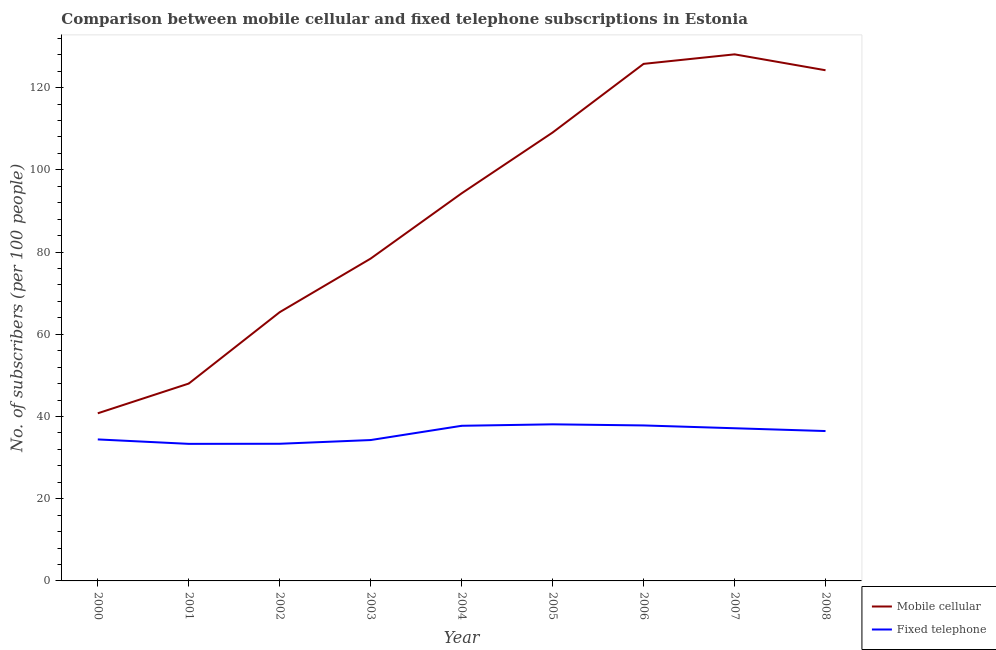Does the line corresponding to number of mobile cellular subscribers intersect with the line corresponding to number of fixed telephone subscribers?
Make the answer very short. No. Is the number of lines equal to the number of legend labels?
Make the answer very short. Yes. What is the number of mobile cellular subscribers in 2008?
Provide a succinct answer. 124.21. Across all years, what is the maximum number of fixed telephone subscribers?
Give a very brief answer. 38.09. Across all years, what is the minimum number of fixed telephone subscribers?
Make the answer very short. 33.34. In which year was the number of mobile cellular subscribers minimum?
Provide a succinct answer. 2000. What is the total number of mobile cellular subscribers in the graph?
Your answer should be very brief. 813.96. What is the difference between the number of mobile cellular subscribers in 2002 and that in 2007?
Provide a short and direct response. -62.71. What is the difference between the number of fixed telephone subscribers in 2003 and the number of mobile cellular subscribers in 2001?
Provide a succinct answer. -13.74. What is the average number of fixed telephone subscribers per year?
Make the answer very short. 35.85. In the year 2003, what is the difference between the number of mobile cellular subscribers and number of fixed telephone subscribers?
Provide a short and direct response. 44.14. What is the ratio of the number of mobile cellular subscribers in 2001 to that in 2008?
Give a very brief answer. 0.39. What is the difference between the highest and the second highest number of fixed telephone subscribers?
Ensure brevity in your answer.  0.27. What is the difference between the highest and the lowest number of mobile cellular subscribers?
Ensure brevity in your answer.  87.31. Does the number of fixed telephone subscribers monotonically increase over the years?
Provide a short and direct response. No. Is the number of fixed telephone subscribers strictly greater than the number of mobile cellular subscribers over the years?
Your answer should be very brief. No. How many years are there in the graph?
Keep it short and to the point. 9. Are the values on the major ticks of Y-axis written in scientific E-notation?
Offer a very short reply. No. Does the graph contain grids?
Keep it short and to the point. No. How many legend labels are there?
Keep it short and to the point. 2. How are the legend labels stacked?
Your response must be concise. Vertical. What is the title of the graph?
Offer a terse response. Comparison between mobile cellular and fixed telephone subscriptions in Estonia. Does "Not attending school" appear as one of the legend labels in the graph?
Provide a short and direct response. No. What is the label or title of the Y-axis?
Keep it short and to the point. No. of subscribers (per 100 people). What is the No. of subscribers (per 100 people) of Mobile cellular in 2000?
Offer a very short reply. 40.77. What is the No. of subscribers (per 100 people) of Fixed telephone in 2000?
Keep it short and to the point. 34.42. What is the No. of subscribers (per 100 people) in Mobile cellular in 2001?
Your answer should be very brief. 48. What is the No. of subscribers (per 100 people) of Fixed telephone in 2001?
Make the answer very short. 33.34. What is the No. of subscribers (per 100 people) of Mobile cellular in 2002?
Offer a very short reply. 65.37. What is the No. of subscribers (per 100 people) in Fixed telephone in 2002?
Your answer should be compact. 33.36. What is the No. of subscribers (per 100 people) of Mobile cellular in 2003?
Provide a short and direct response. 78.41. What is the No. of subscribers (per 100 people) in Fixed telephone in 2003?
Offer a very short reply. 34.26. What is the No. of subscribers (per 100 people) of Mobile cellular in 2004?
Make the answer very short. 94.28. What is the No. of subscribers (per 100 people) of Fixed telephone in 2004?
Keep it short and to the point. 37.73. What is the No. of subscribers (per 100 people) of Mobile cellular in 2005?
Provide a short and direct response. 109.07. What is the No. of subscribers (per 100 people) of Fixed telephone in 2005?
Give a very brief answer. 38.09. What is the No. of subscribers (per 100 people) in Mobile cellular in 2006?
Provide a short and direct response. 125.76. What is the No. of subscribers (per 100 people) of Fixed telephone in 2006?
Give a very brief answer. 37.82. What is the No. of subscribers (per 100 people) in Mobile cellular in 2007?
Provide a short and direct response. 128.08. What is the No. of subscribers (per 100 people) of Fixed telephone in 2007?
Provide a short and direct response. 37.14. What is the No. of subscribers (per 100 people) of Mobile cellular in 2008?
Offer a terse response. 124.21. What is the No. of subscribers (per 100 people) in Fixed telephone in 2008?
Your answer should be compact. 36.45. Across all years, what is the maximum No. of subscribers (per 100 people) of Mobile cellular?
Your answer should be compact. 128.08. Across all years, what is the maximum No. of subscribers (per 100 people) of Fixed telephone?
Ensure brevity in your answer.  38.09. Across all years, what is the minimum No. of subscribers (per 100 people) of Mobile cellular?
Provide a short and direct response. 40.77. Across all years, what is the minimum No. of subscribers (per 100 people) of Fixed telephone?
Offer a very short reply. 33.34. What is the total No. of subscribers (per 100 people) in Mobile cellular in the graph?
Ensure brevity in your answer.  813.96. What is the total No. of subscribers (per 100 people) in Fixed telephone in the graph?
Keep it short and to the point. 322.61. What is the difference between the No. of subscribers (per 100 people) in Mobile cellular in 2000 and that in 2001?
Provide a succinct answer. -7.23. What is the difference between the No. of subscribers (per 100 people) in Fixed telephone in 2000 and that in 2001?
Your response must be concise. 1.08. What is the difference between the No. of subscribers (per 100 people) of Mobile cellular in 2000 and that in 2002?
Your answer should be compact. -24.6. What is the difference between the No. of subscribers (per 100 people) of Fixed telephone in 2000 and that in 2002?
Ensure brevity in your answer.  1.06. What is the difference between the No. of subscribers (per 100 people) in Mobile cellular in 2000 and that in 2003?
Your answer should be very brief. -37.64. What is the difference between the No. of subscribers (per 100 people) in Fixed telephone in 2000 and that in 2003?
Offer a very short reply. 0.15. What is the difference between the No. of subscribers (per 100 people) of Mobile cellular in 2000 and that in 2004?
Provide a succinct answer. -53.51. What is the difference between the No. of subscribers (per 100 people) in Fixed telephone in 2000 and that in 2004?
Your answer should be compact. -3.32. What is the difference between the No. of subscribers (per 100 people) in Mobile cellular in 2000 and that in 2005?
Keep it short and to the point. -68.3. What is the difference between the No. of subscribers (per 100 people) in Fixed telephone in 2000 and that in 2005?
Your response must be concise. -3.67. What is the difference between the No. of subscribers (per 100 people) in Mobile cellular in 2000 and that in 2006?
Provide a short and direct response. -84.99. What is the difference between the No. of subscribers (per 100 people) of Fixed telephone in 2000 and that in 2006?
Your answer should be compact. -3.4. What is the difference between the No. of subscribers (per 100 people) of Mobile cellular in 2000 and that in 2007?
Ensure brevity in your answer.  -87.31. What is the difference between the No. of subscribers (per 100 people) of Fixed telephone in 2000 and that in 2007?
Keep it short and to the point. -2.72. What is the difference between the No. of subscribers (per 100 people) of Mobile cellular in 2000 and that in 2008?
Your answer should be compact. -83.44. What is the difference between the No. of subscribers (per 100 people) of Fixed telephone in 2000 and that in 2008?
Your answer should be very brief. -2.04. What is the difference between the No. of subscribers (per 100 people) of Mobile cellular in 2001 and that in 2002?
Give a very brief answer. -17.37. What is the difference between the No. of subscribers (per 100 people) of Fixed telephone in 2001 and that in 2002?
Your answer should be very brief. -0.02. What is the difference between the No. of subscribers (per 100 people) of Mobile cellular in 2001 and that in 2003?
Your response must be concise. -30.4. What is the difference between the No. of subscribers (per 100 people) in Fixed telephone in 2001 and that in 2003?
Your answer should be very brief. -0.93. What is the difference between the No. of subscribers (per 100 people) of Mobile cellular in 2001 and that in 2004?
Your answer should be very brief. -46.27. What is the difference between the No. of subscribers (per 100 people) of Fixed telephone in 2001 and that in 2004?
Make the answer very short. -4.4. What is the difference between the No. of subscribers (per 100 people) of Mobile cellular in 2001 and that in 2005?
Offer a terse response. -61.07. What is the difference between the No. of subscribers (per 100 people) in Fixed telephone in 2001 and that in 2005?
Offer a terse response. -4.75. What is the difference between the No. of subscribers (per 100 people) in Mobile cellular in 2001 and that in 2006?
Your answer should be very brief. -77.76. What is the difference between the No. of subscribers (per 100 people) of Fixed telephone in 2001 and that in 2006?
Make the answer very short. -4.48. What is the difference between the No. of subscribers (per 100 people) of Mobile cellular in 2001 and that in 2007?
Provide a succinct answer. -80.07. What is the difference between the No. of subscribers (per 100 people) in Fixed telephone in 2001 and that in 2007?
Your answer should be compact. -3.8. What is the difference between the No. of subscribers (per 100 people) of Mobile cellular in 2001 and that in 2008?
Your answer should be very brief. -76.21. What is the difference between the No. of subscribers (per 100 people) of Fixed telephone in 2001 and that in 2008?
Provide a succinct answer. -3.12. What is the difference between the No. of subscribers (per 100 people) in Mobile cellular in 2002 and that in 2003?
Provide a short and direct response. -13.04. What is the difference between the No. of subscribers (per 100 people) in Fixed telephone in 2002 and that in 2003?
Your answer should be compact. -0.91. What is the difference between the No. of subscribers (per 100 people) in Mobile cellular in 2002 and that in 2004?
Give a very brief answer. -28.91. What is the difference between the No. of subscribers (per 100 people) in Fixed telephone in 2002 and that in 2004?
Provide a succinct answer. -4.37. What is the difference between the No. of subscribers (per 100 people) of Mobile cellular in 2002 and that in 2005?
Make the answer very short. -43.7. What is the difference between the No. of subscribers (per 100 people) of Fixed telephone in 2002 and that in 2005?
Give a very brief answer. -4.73. What is the difference between the No. of subscribers (per 100 people) of Mobile cellular in 2002 and that in 2006?
Give a very brief answer. -60.39. What is the difference between the No. of subscribers (per 100 people) in Fixed telephone in 2002 and that in 2006?
Offer a terse response. -4.46. What is the difference between the No. of subscribers (per 100 people) in Mobile cellular in 2002 and that in 2007?
Your response must be concise. -62.71. What is the difference between the No. of subscribers (per 100 people) of Fixed telephone in 2002 and that in 2007?
Your response must be concise. -3.78. What is the difference between the No. of subscribers (per 100 people) of Mobile cellular in 2002 and that in 2008?
Offer a very short reply. -58.84. What is the difference between the No. of subscribers (per 100 people) of Fixed telephone in 2002 and that in 2008?
Give a very brief answer. -3.1. What is the difference between the No. of subscribers (per 100 people) in Mobile cellular in 2003 and that in 2004?
Offer a very short reply. -15.87. What is the difference between the No. of subscribers (per 100 people) of Fixed telephone in 2003 and that in 2004?
Give a very brief answer. -3.47. What is the difference between the No. of subscribers (per 100 people) of Mobile cellular in 2003 and that in 2005?
Keep it short and to the point. -30.66. What is the difference between the No. of subscribers (per 100 people) of Fixed telephone in 2003 and that in 2005?
Ensure brevity in your answer.  -3.82. What is the difference between the No. of subscribers (per 100 people) in Mobile cellular in 2003 and that in 2006?
Your response must be concise. -47.36. What is the difference between the No. of subscribers (per 100 people) of Fixed telephone in 2003 and that in 2006?
Your answer should be compact. -3.55. What is the difference between the No. of subscribers (per 100 people) in Mobile cellular in 2003 and that in 2007?
Give a very brief answer. -49.67. What is the difference between the No. of subscribers (per 100 people) of Fixed telephone in 2003 and that in 2007?
Provide a short and direct response. -2.87. What is the difference between the No. of subscribers (per 100 people) in Mobile cellular in 2003 and that in 2008?
Make the answer very short. -45.8. What is the difference between the No. of subscribers (per 100 people) in Fixed telephone in 2003 and that in 2008?
Provide a short and direct response. -2.19. What is the difference between the No. of subscribers (per 100 people) of Mobile cellular in 2004 and that in 2005?
Your answer should be compact. -14.79. What is the difference between the No. of subscribers (per 100 people) of Fixed telephone in 2004 and that in 2005?
Your response must be concise. -0.35. What is the difference between the No. of subscribers (per 100 people) in Mobile cellular in 2004 and that in 2006?
Keep it short and to the point. -31.49. What is the difference between the No. of subscribers (per 100 people) in Fixed telephone in 2004 and that in 2006?
Keep it short and to the point. -0.08. What is the difference between the No. of subscribers (per 100 people) of Mobile cellular in 2004 and that in 2007?
Keep it short and to the point. -33.8. What is the difference between the No. of subscribers (per 100 people) of Fixed telephone in 2004 and that in 2007?
Your response must be concise. 0.6. What is the difference between the No. of subscribers (per 100 people) of Mobile cellular in 2004 and that in 2008?
Provide a short and direct response. -29.93. What is the difference between the No. of subscribers (per 100 people) of Fixed telephone in 2004 and that in 2008?
Provide a succinct answer. 1.28. What is the difference between the No. of subscribers (per 100 people) of Mobile cellular in 2005 and that in 2006?
Provide a short and direct response. -16.69. What is the difference between the No. of subscribers (per 100 people) of Fixed telephone in 2005 and that in 2006?
Your answer should be very brief. 0.27. What is the difference between the No. of subscribers (per 100 people) of Mobile cellular in 2005 and that in 2007?
Keep it short and to the point. -19.01. What is the difference between the No. of subscribers (per 100 people) of Fixed telephone in 2005 and that in 2007?
Make the answer very short. 0.95. What is the difference between the No. of subscribers (per 100 people) in Mobile cellular in 2005 and that in 2008?
Make the answer very short. -15.14. What is the difference between the No. of subscribers (per 100 people) in Fixed telephone in 2005 and that in 2008?
Make the answer very short. 1.63. What is the difference between the No. of subscribers (per 100 people) of Mobile cellular in 2006 and that in 2007?
Your answer should be very brief. -2.31. What is the difference between the No. of subscribers (per 100 people) in Fixed telephone in 2006 and that in 2007?
Your response must be concise. 0.68. What is the difference between the No. of subscribers (per 100 people) of Mobile cellular in 2006 and that in 2008?
Offer a terse response. 1.55. What is the difference between the No. of subscribers (per 100 people) in Fixed telephone in 2006 and that in 2008?
Your answer should be very brief. 1.36. What is the difference between the No. of subscribers (per 100 people) in Mobile cellular in 2007 and that in 2008?
Give a very brief answer. 3.87. What is the difference between the No. of subscribers (per 100 people) in Fixed telephone in 2007 and that in 2008?
Offer a terse response. 0.68. What is the difference between the No. of subscribers (per 100 people) in Mobile cellular in 2000 and the No. of subscribers (per 100 people) in Fixed telephone in 2001?
Make the answer very short. 7.43. What is the difference between the No. of subscribers (per 100 people) in Mobile cellular in 2000 and the No. of subscribers (per 100 people) in Fixed telephone in 2002?
Give a very brief answer. 7.41. What is the difference between the No. of subscribers (per 100 people) of Mobile cellular in 2000 and the No. of subscribers (per 100 people) of Fixed telephone in 2003?
Give a very brief answer. 6.51. What is the difference between the No. of subscribers (per 100 people) of Mobile cellular in 2000 and the No. of subscribers (per 100 people) of Fixed telephone in 2004?
Provide a succinct answer. 3.04. What is the difference between the No. of subscribers (per 100 people) in Mobile cellular in 2000 and the No. of subscribers (per 100 people) in Fixed telephone in 2005?
Keep it short and to the point. 2.68. What is the difference between the No. of subscribers (per 100 people) of Mobile cellular in 2000 and the No. of subscribers (per 100 people) of Fixed telephone in 2006?
Provide a short and direct response. 2.95. What is the difference between the No. of subscribers (per 100 people) in Mobile cellular in 2000 and the No. of subscribers (per 100 people) in Fixed telephone in 2007?
Provide a short and direct response. 3.64. What is the difference between the No. of subscribers (per 100 people) in Mobile cellular in 2000 and the No. of subscribers (per 100 people) in Fixed telephone in 2008?
Your answer should be compact. 4.32. What is the difference between the No. of subscribers (per 100 people) of Mobile cellular in 2001 and the No. of subscribers (per 100 people) of Fixed telephone in 2002?
Ensure brevity in your answer.  14.65. What is the difference between the No. of subscribers (per 100 people) in Mobile cellular in 2001 and the No. of subscribers (per 100 people) in Fixed telephone in 2003?
Provide a succinct answer. 13.74. What is the difference between the No. of subscribers (per 100 people) of Mobile cellular in 2001 and the No. of subscribers (per 100 people) of Fixed telephone in 2004?
Make the answer very short. 10.27. What is the difference between the No. of subscribers (per 100 people) in Mobile cellular in 2001 and the No. of subscribers (per 100 people) in Fixed telephone in 2005?
Your answer should be very brief. 9.92. What is the difference between the No. of subscribers (per 100 people) of Mobile cellular in 2001 and the No. of subscribers (per 100 people) of Fixed telephone in 2006?
Your answer should be compact. 10.19. What is the difference between the No. of subscribers (per 100 people) in Mobile cellular in 2001 and the No. of subscribers (per 100 people) in Fixed telephone in 2007?
Your answer should be very brief. 10.87. What is the difference between the No. of subscribers (per 100 people) in Mobile cellular in 2001 and the No. of subscribers (per 100 people) in Fixed telephone in 2008?
Provide a short and direct response. 11.55. What is the difference between the No. of subscribers (per 100 people) in Mobile cellular in 2002 and the No. of subscribers (per 100 people) in Fixed telephone in 2003?
Your answer should be compact. 31.11. What is the difference between the No. of subscribers (per 100 people) of Mobile cellular in 2002 and the No. of subscribers (per 100 people) of Fixed telephone in 2004?
Give a very brief answer. 27.64. What is the difference between the No. of subscribers (per 100 people) in Mobile cellular in 2002 and the No. of subscribers (per 100 people) in Fixed telephone in 2005?
Your response must be concise. 27.28. What is the difference between the No. of subscribers (per 100 people) of Mobile cellular in 2002 and the No. of subscribers (per 100 people) of Fixed telephone in 2006?
Your response must be concise. 27.55. What is the difference between the No. of subscribers (per 100 people) of Mobile cellular in 2002 and the No. of subscribers (per 100 people) of Fixed telephone in 2007?
Give a very brief answer. 28.24. What is the difference between the No. of subscribers (per 100 people) of Mobile cellular in 2002 and the No. of subscribers (per 100 people) of Fixed telephone in 2008?
Your answer should be compact. 28.92. What is the difference between the No. of subscribers (per 100 people) of Mobile cellular in 2003 and the No. of subscribers (per 100 people) of Fixed telephone in 2004?
Provide a short and direct response. 40.67. What is the difference between the No. of subscribers (per 100 people) of Mobile cellular in 2003 and the No. of subscribers (per 100 people) of Fixed telephone in 2005?
Offer a very short reply. 40.32. What is the difference between the No. of subscribers (per 100 people) in Mobile cellular in 2003 and the No. of subscribers (per 100 people) in Fixed telephone in 2006?
Keep it short and to the point. 40.59. What is the difference between the No. of subscribers (per 100 people) of Mobile cellular in 2003 and the No. of subscribers (per 100 people) of Fixed telephone in 2007?
Offer a terse response. 41.27. What is the difference between the No. of subscribers (per 100 people) of Mobile cellular in 2003 and the No. of subscribers (per 100 people) of Fixed telephone in 2008?
Offer a terse response. 41.95. What is the difference between the No. of subscribers (per 100 people) in Mobile cellular in 2004 and the No. of subscribers (per 100 people) in Fixed telephone in 2005?
Your response must be concise. 56.19. What is the difference between the No. of subscribers (per 100 people) of Mobile cellular in 2004 and the No. of subscribers (per 100 people) of Fixed telephone in 2006?
Ensure brevity in your answer.  56.46. What is the difference between the No. of subscribers (per 100 people) in Mobile cellular in 2004 and the No. of subscribers (per 100 people) in Fixed telephone in 2007?
Make the answer very short. 57.14. What is the difference between the No. of subscribers (per 100 people) in Mobile cellular in 2004 and the No. of subscribers (per 100 people) in Fixed telephone in 2008?
Provide a short and direct response. 57.82. What is the difference between the No. of subscribers (per 100 people) in Mobile cellular in 2005 and the No. of subscribers (per 100 people) in Fixed telephone in 2006?
Your answer should be very brief. 71.25. What is the difference between the No. of subscribers (per 100 people) in Mobile cellular in 2005 and the No. of subscribers (per 100 people) in Fixed telephone in 2007?
Your answer should be very brief. 71.94. What is the difference between the No. of subscribers (per 100 people) in Mobile cellular in 2005 and the No. of subscribers (per 100 people) in Fixed telephone in 2008?
Keep it short and to the point. 72.62. What is the difference between the No. of subscribers (per 100 people) of Mobile cellular in 2006 and the No. of subscribers (per 100 people) of Fixed telephone in 2007?
Your response must be concise. 88.63. What is the difference between the No. of subscribers (per 100 people) in Mobile cellular in 2006 and the No. of subscribers (per 100 people) in Fixed telephone in 2008?
Give a very brief answer. 89.31. What is the difference between the No. of subscribers (per 100 people) in Mobile cellular in 2007 and the No. of subscribers (per 100 people) in Fixed telephone in 2008?
Provide a short and direct response. 91.62. What is the average No. of subscribers (per 100 people) of Mobile cellular per year?
Provide a short and direct response. 90.44. What is the average No. of subscribers (per 100 people) in Fixed telephone per year?
Provide a succinct answer. 35.85. In the year 2000, what is the difference between the No. of subscribers (per 100 people) in Mobile cellular and No. of subscribers (per 100 people) in Fixed telephone?
Provide a short and direct response. 6.36. In the year 2001, what is the difference between the No. of subscribers (per 100 people) of Mobile cellular and No. of subscribers (per 100 people) of Fixed telephone?
Ensure brevity in your answer.  14.67. In the year 2002, what is the difference between the No. of subscribers (per 100 people) of Mobile cellular and No. of subscribers (per 100 people) of Fixed telephone?
Give a very brief answer. 32.01. In the year 2003, what is the difference between the No. of subscribers (per 100 people) of Mobile cellular and No. of subscribers (per 100 people) of Fixed telephone?
Provide a succinct answer. 44.14. In the year 2004, what is the difference between the No. of subscribers (per 100 people) of Mobile cellular and No. of subscribers (per 100 people) of Fixed telephone?
Your response must be concise. 56.55. In the year 2005, what is the difference between the No. of subscribers (per 100 people) of Mobile cellular and No. of subscribers (per 100 people) of Fixed telephone?
Your answer should be compact. 70.98. In the year 2006, what is the difference between the No. of subscribers (per 100 people) of Mobile cellular and No. of subscribers (per 100 people) of Fixed telephone?
Give a very brief answer. 87.95. In the year 2007, what is the difference between the No. of subscribers (per 100 people) of Mobile cellular and No. of subscribers (per 100 people) of Fixed telephone?
Make the answer very short. 90.94. In the year 2008, what is the difference between the No. of subscribers (per 100 people) in Mobile cellular and No. of subscribers (per 100 people) in Fixed telephone?
Offer a very short reply. 87.76. What is the ratio of the No. of subscribers (per 100 people) in Mobile cellular in 2000 to that in 2001?
Offer a very short reply. 0.85. What is the ratio of the No. of subscribers (per 100 people) in Fixed telephone in 2000 to that in 2001?
Your answer should be compact. 1.03. What is the ratio of the No. of subscribers (per 100 people) in Mobile cellular in 2000 to that in 2002?
Ensure brevity in your answer.  0.62. What is the ratio of the No. of subscribers (per 100 people) of Fixed telephone in 2000 to that in 2002?
Keep it short and to the point. 1.03. What is the ratio of the No. of subscribers (per 100 people) of Mobile cellular in 2000 to that in 2003?
Keep it short and to the point. 0.52. What is the ratio of the No. of subscribers (per 100 people) of Mobile cellular in 2000 to that in 2004?
Provide a short and direct response. 0.43. What is the ratio of the No. of subscribers (per 100 people) in Fixed telephone in 2000 to that in 2004?
Ensure brevity in your answer.  0.91. What is the ratio of the No. of subscribers (per 100 people) in Mobile cellular in 2000 to that in 2005?
Ensure brevity in your answer.  0.37. What is the ratio of the No. of subscribers (per 100 people) in Fixed telephone in 2000 to that in 2005?
Your answer should be compact. 0.9. What is the ratio of the No. of subscribers (per 100 people) of Mobile cellular in 2000 to that in 2006?
Offer a very short reply. 0.32. What is the ratio of the No. of subscribers (per 100 people) in Fixed telephone in 2000 to that in 2006?
Your answer should be compact. 0.91. What is the ratio of the No. of subscribers (per 100 people) in Mobile cellular in 2000 to that in 2007?
Provide a short and direct response. 0.32. What is the ratio of the No. of subscribers (per 100 people) of Fixed telephone in 2000 to that in 2007?
Your answer should be very brief. 0.93. What is the ratio of the No. of subscribers (per 100 people) in Mobile cellular in 2000 to that in 2008?
Keep it short and to the point. 0.33. What is the ratio of the No. of subscribers (per 100 people) in Fixed telephone in 2000 to that in 2008?
Your response must be concise. 0.94. What is the ratio of the No. of subscribers (per 100 people) of Mobile cellular in 2001 to that in 2002?
Your response must be concise. 0.73. What is the ratio of the No. of subscribers (per 100 people) in Mobile cellular in 2001 to that in 2003?
Your response must be concise. 0.61. What is the ratio of the No. of subscribers (per 100 people) of Fixed telephone in 2001 to that in 2003?
Make the answer very short. 0.97. What is the ratio of the No. of subscribers (per 100 people) in Mobile cellular in 2001 to that in 2004?
Provide a succinct answer. 0.51. What is the ratio of the No. of subscribers (per 100 people) in Fixed telephone in 2001 to that in 2004?
Provide a short and direct response. 0.88. What is the ratio of the No. of subscribers (per 100 people) of Mobile cellular in 2001 to that in 2005?
Provide a short and direct response. 0.44. What is the ratio of the No. of subscribers (per 100 people) of Fixed telephone in 2001 to that in 2005?
Offer a very short reply. 0.88. What is the ratio of the No. of subscribers (per 100 people) of Mobile cellular in 2001 to that in 2006?
Your response must be concise. 0.38. What is the ratio of the No. of subscribers (per 100 people) of Fixed telephone in 2001 to that in 2006?
Provide a short and direct response. 0.88. What is the ratio of the No. of subscribers (per 100 people) in Mobile cellular in 2001 to that in 2007?
Offer a terse response. 0.37. What is the ratio of the No. of subscribers (per 100 people) of Fixed telephone in 2001 to that in 2007?
Your response must be concise. 0.9. What is the ratio of the No. of subscribers (per 100 people) in Mobile cellular in 2001 to that in 2008?
Ensure brevity in your answer.  0.39. What is the ratio of the No. of subscribers (per 100 people) of Fixed telephone in 2001 to that in 2008?
Your response must be concise. 0.91. What is the ratio of the No. of subscribers (per 100 people) of Mobile cellular in 2002 to that in 2003?
Ensure brevity in your answer.  0.83. What is the ratio of the No. of subscribers (per 100 people) in Fixed telephone in 2002 to that in 2003?
Your answer should be very brief. 0.97. What is the ratio of the No. of subscribers (per 100 people) in Mobile cellular in 2002 to that in 2004?
Provide a short and direct response. 0.69. What is the ratio of the No. of subscribers (per 100 people) of Fixed telephone in 2002 to that in 2004?
Your response must be concise. 0.88. What is the ratio of the No. of subscribers (per 100 people) of Mobile cellular in 2002 to that in 2005?
Your answer should be compact. 0.6. What is the ratio of the No. of subscribers (per 100 people) in Fixed telephone in 2002 to that in 2005?
Your answer should be very brief. 0.88. What is the ratio of the No. of subscribers (per 100 people) of Mobile cellular in 2002 to that in 2006?
Provide a succinct answer. 0.52. What is the ratio of the No. of subscribers (per 100 people) in Fixed telephone in 2002 to that in 2006?
Give a very brief answer. 0.88. What is the ratio of the No. of subscribers (per 100 people) of Mobile cellular in 2002 to that in 2007?
Make the answer very short. 0.51. What is the ratio of the No. of subscribers (per 100 people) in Fixed telephone in 2002 to that in 2007?
Ensure brevity in your answer.  0.9. What is the ratio of the No. of subscribers (per 100 people) in Mobile cellular in 2002 to that in 2008?
Offer a terse response. 0.53. What is the ratio of the No. of subscribers (per 100 people) of Fixed telephone in 2002 to that in 2008?
Provide a succinct answer. 0.92. What is the ratio of the No. of subscribers (per 100 people) in Mobile cellular in 2003 to that in 2004?
Ensure brevity in your answer.  0.83. What is the ratio of the No. of subscribers (per 100 people) in Fixed telephone in 2003 to that in 2004?
Give a very brief answer. 0.91. What is the ratio of the No. of subscribers (per 100 people) of Mobile cellular in 2003 to that in 2005?
Provide a short and direct response. 0.72. What is the ratio of the No. of subscribers (per 100 people) of Fixed telephone in 2003 to that in 2005?
Your answer should be compact. 0.9. What is the ratio of the No. of subscribers (per 100 people) of Mobile cellular in 2003 to that in 2006?
Your answer should be very brief. 0.62. What is the ratio of the No. of subscribers (per 100 people) in Fixed telephone in 2003 to that in 2006?
Your answer should be very brief. 0.91. What is the ratio of the No. of subscribers (per 100 people) of Mobile cellular in 2003 to that in 2007?
Provide a succinct answer. 0.61. What is the ratio of the No. of subscribers (per 100 people) in Fixed telephone in 2003 to that in 2007?
Ensure brevity in your answer.  0.92. What is the ratio of the No. of subscribers (per 100 people) of Mobile cellular in 2003 to that in 2008?
Offer a very short reply. 0.63. What is the ratio of the No. of subscribers (per 100 people) of Fixed telephone in 2003 to that in 2008?
Your answer should be compact. 0.94. What is the ratio of the No. of subscribers (per 100 people) of Mobile cellular in 2004 to that in 2005?
Ensure brevity in your answer.  0.86. What is the ratio of the No. of subscribers (per 100 people) of Mobile cellular in 2004 to that in 2006?
Provide a succinct answer. 0.75. What is the ratio of the No. of subscribers (per 100 people) in Fixed telephone in 2004 to that in 2006?
Make the answer very short. 1. What is the ratio of the No. of subscribers (per 100 people) in Mobile cellular in 2004 to that in 2007?
Your response must be concise. 0.74. What is the ratio of the No. of subscribers (per 100 people) of Fixed telephone in 2004 to that in 2007?
Provide a short and direct response. 1.02. What is the ratio of the No. of subscribers (per 100 people) of Mobile cellular in 2004 to that in 2008?
Your response must be concise. 0.76. What is the ratio of the No. of subscribers (per 100 people) of Fixed telephone in 2004 to that in 2008?
Offer a very short reply. 1.04. What is the ratio of the No. of subscribers (per 100 people) in Mobile cellular in 2005 to that in 2006?
Your answer should be compact. 0.87. What is the ratio of the No. of subscribers (per 100 people) of Fixed telephone in 2005 to that in 2006?
Keep it short and to the point. 1.01. What is the ratio of the No. of subscribers (per 100 people) in Mobile cellular in 2005 to that in 2007?
Keep it short and to the point. 0.85. What is the ratio of the No. of subscribers (per 100 people) in Fixed telephone in 2005 to that in 2007?
Your answer should be very brief. 1.03. What is the ratio of the No. of subscribers (per 100 people) in Mobile cellular in 2005 to that in 2008?
Give a very brief answer. 0.88. What is the ratio of the No. of subscribers (per 100 people) of Fixed telephone in 2005 to that in 2008?
Your response must be concise. 1.04. What is the ratio of the No. of subscribers (per 100 people) in Mobile cellular in 2006 to that in 2007?
Give a very brief answer. 0.98. What is the ratio of the No. of subscribers (per 100 people) in Fixed telephone in 2006 to that in 2007?
Keep it short and to the point. 1.02. What is the ratio of the No. of subscribers (per 100 people) of Mobile cellular in 2006 to that in 2008?
Keep it short and to the point. 1.01. What is the ratio of the No. of subscribers (per 100 people) of Fixed telephone in 2006 to that in 2008?
Offer a terse response. 1.04. What is the ratio of the No. of subscribers (per 100 people) in Mobile cellular in 2007 to that in 2008?
Provide a short and direct response. 1.03. What is the ratio of the No. of subscribers (per 100 people) in Fixed telephone in 2007 to that in 2008?
Keep it short and to the point. 1.02. What is the difference between the highest and the second highest No. of subscribers (per 100 people) of Mobile cellular?
Your response must be concise. 2.31. What is the difference between the highest and the second highest No. of subscribers (per 100 people) in Fixed telephone?
Ensure brevity in your answer.  0.27. What is the difference between the highest and the lowest No. of subscribers (per 100 people) of Mobile cellular?
Your answer should be compact. 87.31. What is the difference between the highest and the lowest No. of subscribers (per 100 people) in Fixed telephone?
Offer a terse response. 4.75. 